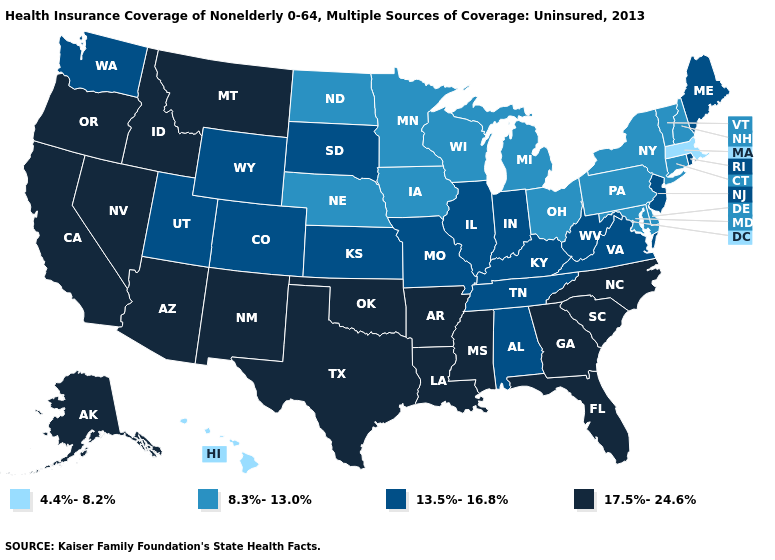Name the states that have a value in the range 17.5%-24.6%?
Give a very brief answer. Alaska, Arizona, Arkansas, California, Florida, Georgia, Idaho, Louisiana, Mississippi, Montana, Nevada, New Mexico, North Carolina, Oklahoma, Oregon, South Carolina, Texas. How many symbols are there in the legend?
Concise answer only. 4. What is the highest value in the MidWest ?
Keep it brief. 13.5%-16.8%. What is the value of Kentucky?
Concise answer only. 13.5%-16.8%. Which states hav the highest value in the MidWest?
Answer briefly. Illinois, Indiana, Kansas, Missouri, South Dakota. Which states have the lowest value in the South?
Short answer required. Delaware, Maryland. Which states have the highest value in the USA?
Answer briefly. Alaska, Arizona, Arkansas, California, Florida, Georgia, Idaho, Louisiana, Mississippi, Montana, Nevada, New Mexico, North Carolina, Oklahoma, Oregon, South Carolina, Texas. Among the states that border Nebraska , does Iowa have the highest value?
Write a very short answer. No. Does Pennsylvania have a higher value than Missouri?
Quick response, please. No. Is the legend a continuous bar?
Give a very brief answer. No. Among the states that border Delaware , does Maryland have the highest value?
Keep it brief. No. Name the states that have a value in the range 4.4%-8.2%?
Short answer required. Hawaii, Massachusetts. What is the lowest value in states that border Colorado?
Concise answer only. 8.3%-13.0%. Among the states that border Idaho , which have the highest value?
Write a very short answer. Montana, Nevada, Oregon. What is the value of Florida?
Quick response, please. 17.5%-24.6%. 